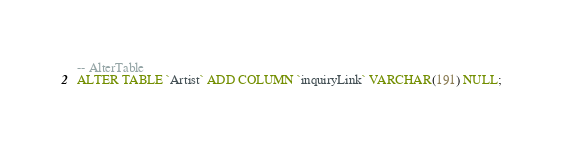Convert code to text. <code><loc_0><loc_0><loc_500><loc_500><_SQL_>-- AlterTable
ALTER TABLE `Artist` ADD COLUMN `inquiryLink` VARCHAR(191) NULL;
</code> 